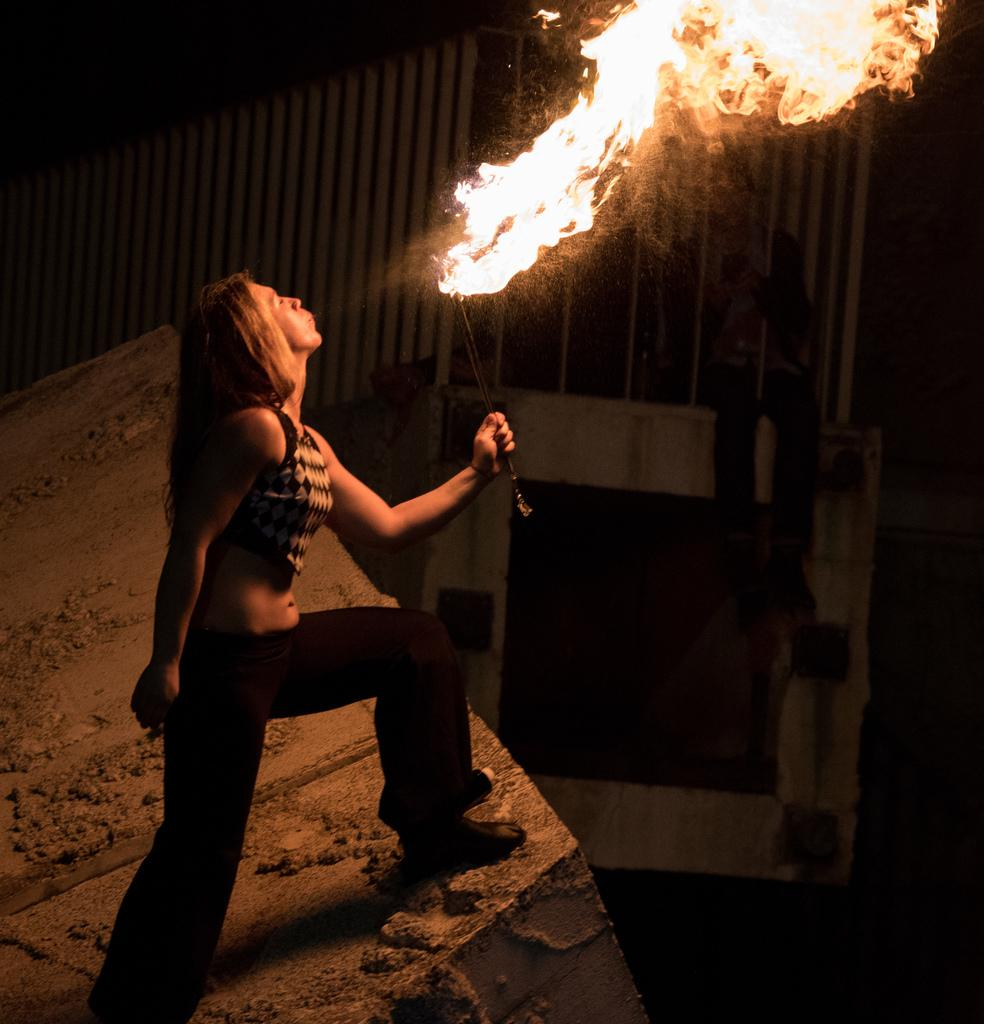Who is the main subject in the image? There is a woman in the image. What is the woman doing in the image? The woman is standing on the floor and blowing fire. Can you describe the other person in the image? There is another person in the background of the image. What type of salt is being used by the woman in the image? There is no salt present in the image; the woman is blowing fire. How does the woman's mind affect the fire in the image? The image does not provide any information about the woman's mind or its effect on the fire. 